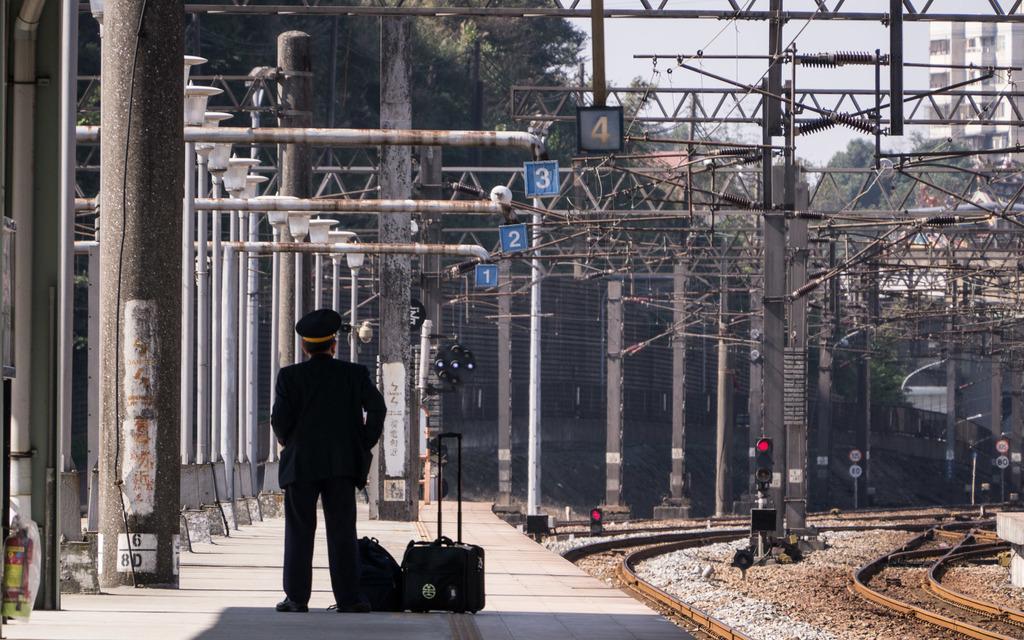Please provide a concise description of this image. In this picture I see the platform in front on which there is a man and I see bats near him. In the middle of this picture I see number of poles and I see few signals. On the right side of this image I see the tracks. In the background I see number of trees, sky and I see a building on the top right corner. 